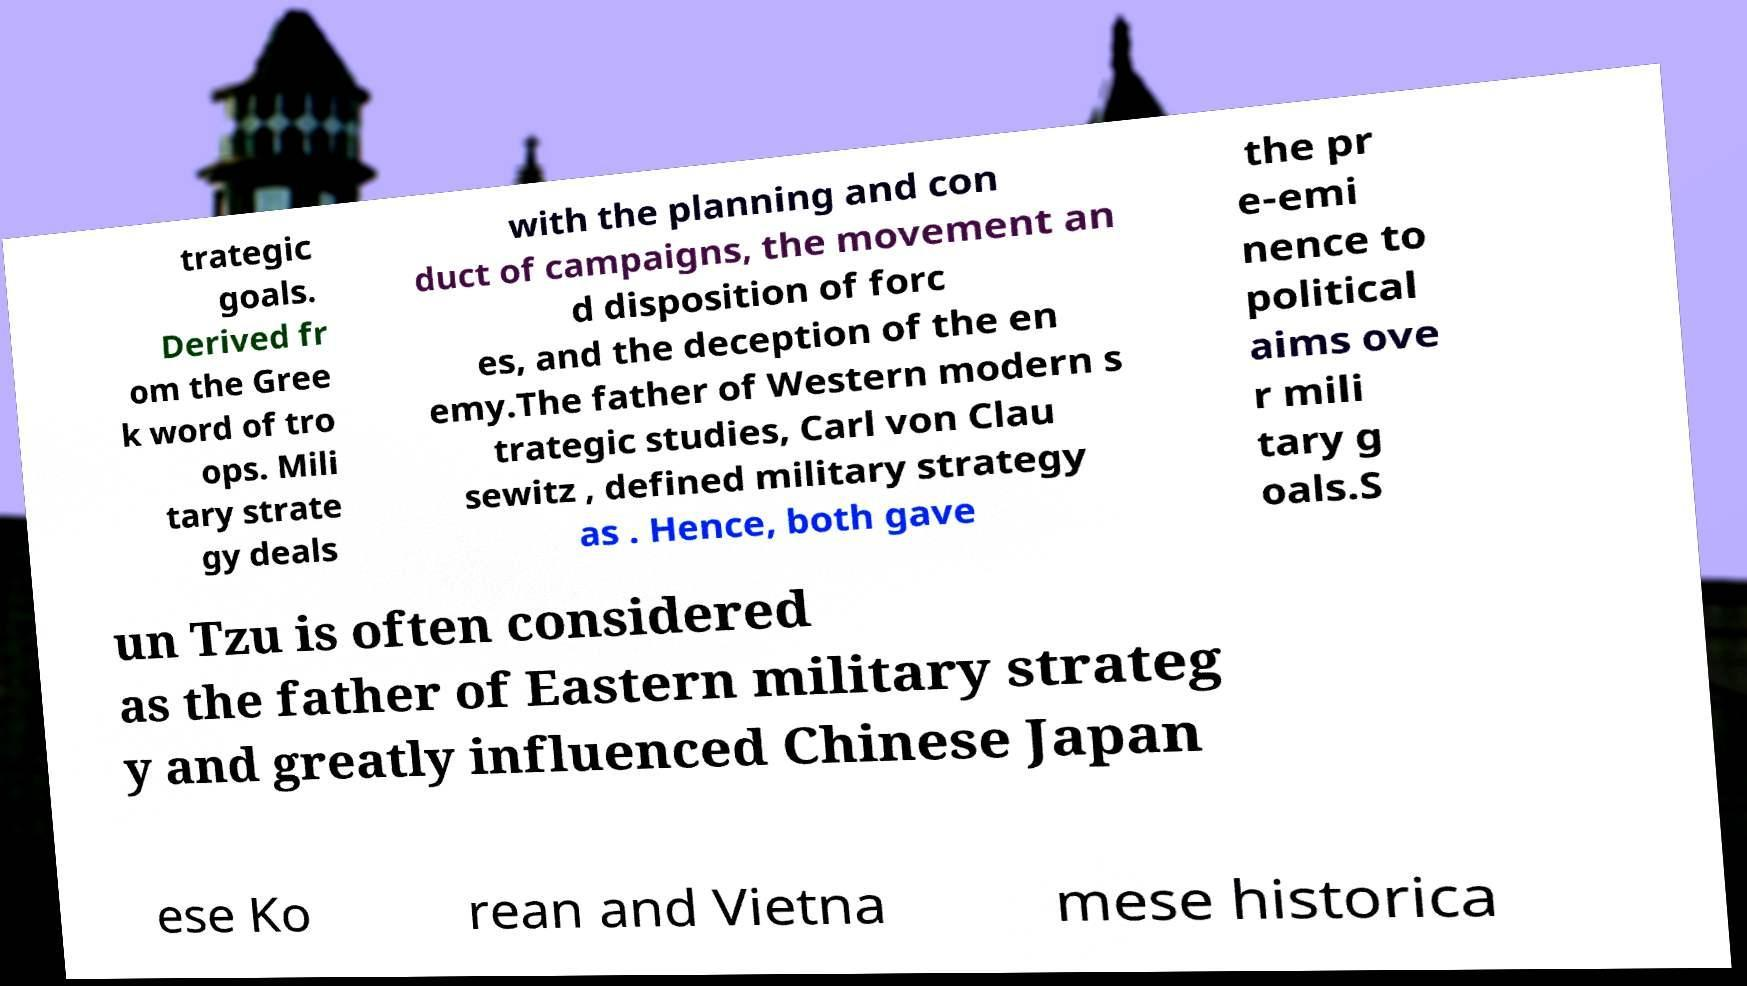What messages or text are displayed in this image? I need them in a readable, typed format. trategic goals. Derived fr om the Gree k word of tro ops. Mili tary strate gy deals with the planning and con duct of campaigns, the movement an d disposition of forc es, and the deception of the en emy.The father of Western modern s trategic studies, Carl von Clau sewitz , defined military strategy as . Hence, both gave the pr e-emi nence to political aims ove r mili tary g oals.S un Tzu is often considered as the father of Eastern military strateg y and greatly influenced Chinese Japan ese Ko rean and Vietna mese historica 